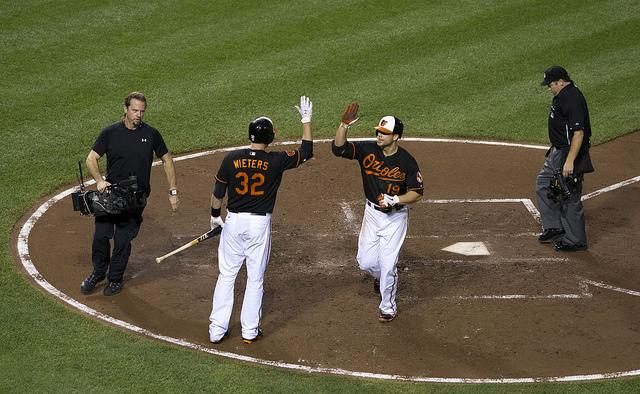Where did 19 just step away from? Please explain your reasoning. home base. 19 is walking away from home plate. 